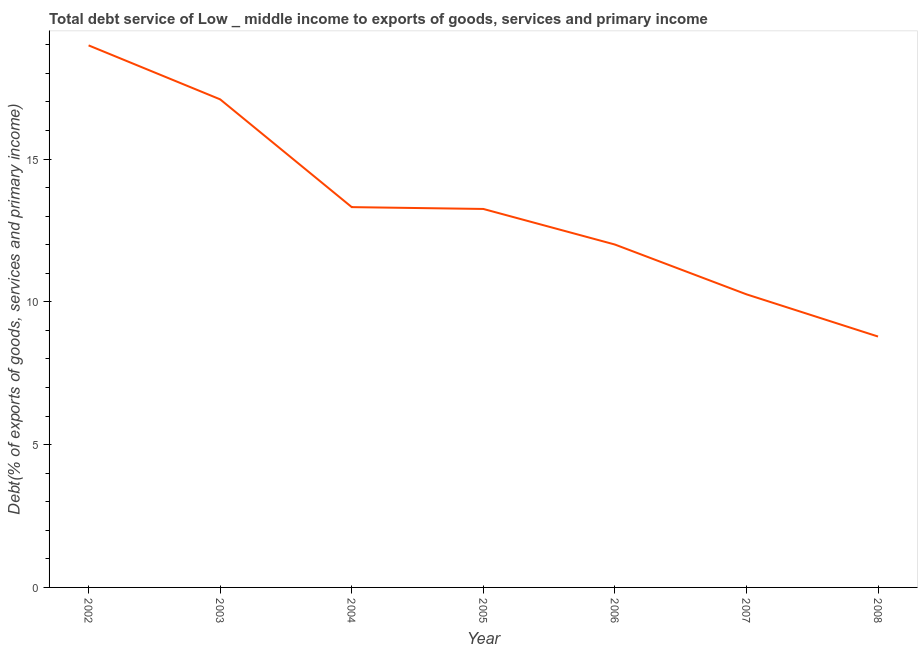What is the total debt service in 2002?
Offer a very short reply. 18.98. Across all years, what is the maximum total debt service?
Provide a succinct answer. 18.98. Across all years, what is the minimum total debt service?
Your answer should be very brief. 8.79. In which year was the total debt service minimum?
Your response must be concise. 2008. What is the sum of the total debt service?
Ensure brevity in your answer.  93.7. What is the difference between the total debt service in 2003 and 2005?
Provide a succinct answer. 3.84. What is the average total debt service per year?
Give a very brief answer. 13.39. What is the median total debt service?
Offer a very short reply. 13.25. In how many years, is the total debt service greater than 14 %?
Your answer should be very brief. 2. Do a majority of the years between 2006 and 2008 (inclusive) have total debt service greater than 17 %?
Give a very brief answer. No. What is the ratio of the total debt service in 2003 to that in 2008?
Offer a terse response. 1.95. Is the difference between the total debt service in 2007 and 2008 greater than the difference between any two years?
Your answer should be compact. No. What is the difference between the highest and the second highest total debt service?
Provide a succinct answer. 1.89. What is the difference between the highest and the lowest total debt service?
Make the answer very short. 10.2. Does the total debt service monotonically increase over the years?
Your answer should be very brief. No. How many lines are there?
Offer a very short reply. 1. Are the values on the major ticks of Y-axis written in scientific E-notation?
Ensure brevity in your answer.  No. What is the title of the graph?
Provide a short and direct response. Total debt service of Low _ middle income to exports of goods, services and primary income. What is the label or title of the X-axis?
Your response must be concise. Year. What is the label or title of the Y-axis?
Offer a very short reply. Debt(% of exports of goods, services and primary income). What is the Debt(% of exports of goods, services and primary income) in 2002?
Offer a terse response. 18.98. What is the Debt(% of exports of goods, services and primary income) in 2003?
Make the answer very short. 17.09. What is the Debt(% of exports of goods, services and primary income) of 2004?
Give a very brief answer. 13.32. What is the Debt(% of exports of goods, services and primary income) in 2005?
Offer a terse response. 13.25. What is the Debt(% of exports of goods, services and primary income) in 2006?
Your response must be concise. 12.01. What is the Debt(% of exports of goods, services and primary income) of 2007?
Offer a terse response. 10.26. What is the Debt(% of exports of goods, services and primary income) in 2008?
Your answer should be compact. 8.79. What is the difference between the Debt(% of exports of goods, services and primary income) in 2002 and 2003?
Ensure brevity in your answer.  1.89. What is the difference between the Debt(% of exports of goods, services and primary income) in 2002 and 2004?
Offer a terse response. 5.66. What is the difference between the Debt(% of exports of goods, services and primary income) in 2002 and 2005?
Your response must be concise. 5.73. What is the difference between the Debt(% of exports of goods, services and primary income) in 2002 and 2006?
Your answer should be compact. 6.97. What is the difference between the Debt(% of exports of goods, services and primary income) in 2002 and 2007?
Provide a short and direct response. 8.72. What is the difference between the Debt(% of exports of goods, services and primary income) in 2002 and 2008?
Give a very brief answer. 10.2. What is the difference between the Debt(% of exports of goods, services and primary income) in 2003 and 2004?
Offer a terse response. 3.77. What is the difference between the Debt(% of exports of goods, services and primary income) in 2003 and 2005?
Provide a short and direct response. 3.84. What is the difference between the Debt(% of exports of goods, services and primary income) in 2003 and 2006?
Give a very brief answer. 5.08. What is the difference between the Debt(% of exports of goods, services and primary income) in 2003 and 2007?
Offer a very short reply. 6.83. What is the difference between the Debt(% of exports of goods, services and primary income) in 2003 and 2008?
Make the answer very short. 8.31. What is the difference between the Debt(% of exports of goods, services and primary income) in 2004 and 2005?
Your answer should be compact. 0.06. What is the difference between the Debt(% of exports of goods, services and primary income) in 2004 and 2006?
Ensure brevity in your answer.  1.31. What is the difference between the Debt(% of exports of goods, services and primary income) in 2004 and 2007?
Make the answer very short. 3.05. What is the difference between the Debt(% of exports of goods, services and primary income) in 2004 and 2008?
Provide a short and direct response. 4.53. What is the difference between the Debt(% of exports of goods, services and primary income) in 2005 and 2006?
Your answer should be very brief. 1.25. What is the difference between the Debt(% of exports of goods, services and primary income) in 2005 and 2007?
Ensure brevity in your answer.  2.99. What is the difference between the Debt(% of exports of goods, services and primary income) in 2005 and 2008?
Ensure brevity in your answer.  4.47. What is the difference between the Debt(% of exports of goods, services and primary income) in 2006 and 2007?
Provide a succinct answer. 1.74. What is the difference between the Debt(% of exports of goods, services and primary income) in 2006 and 2008?
Give a very brief answer. 3.22. What is the difference between the Debt(% of exports of goods, services and primary income) in 2007 and 2008?
Make the answer very short. 1.48. What is the ratio of the Debt(% of exports of goods, services and primary income) in 2002 to that in 2003?
Provide a succinct answer. 1.11. What is the ratio of the Debt(% of exports of goods, services and primary income) in 2002 to that in 2004?
Keep it short and to the point. 1.43. What is the ratio of the Debt(% of exports of goods, services and primary income) in 2002 to that in 2005?
Provide a succinct answer. 1.43. What is the ratio of the Debt(% of exports of goods, services and primary income) in 2002 to that in 2006?
Your answer should be compact. 1.58. What is the ratio of the Debt(% of exports of goods, services and primary income) in 2002 to that in 2007?
Give a very brief answer. 1.85. What is the ratio of the Debt(% of exports of goods, services and primary income) in 2002 to that in 2008?
Offer a terse response. 2.16. What is the ratio of the Debt(% of exports of goods, services and primary income) in 2003 to that in 2004?
Give a very brief answer. 1.28. What is the ratio of the Debt(% of exports of goods, services and primary income) in 2003 to that in 2005?
Offer a terse response. 1.29. What is the ratio of the Debt(% of exports of goods, services and primary income) in 2003 to that in 2006?
Ensure brevity in your answer.  1.42. What is the ratio of the Debt(% of exports of goods, services and primary income) in 2003 to that in 2007?
Offer a terse response. 1.67. What is the ratio of the Debt(% of exports of goods, services and primary income) in 2003 to that in 2008?
Provide a succinct answer. 1.95. What is the ratio of the Debt(% of exports of goods, services and primary income) in 2004 to that in 2006?
Provide a succinct answer. 1.11. What is the ratio of the Debt(% of exports of goods, services and primary income) in 2004 to that in 2007?
Offer a terse response. 1.3. What is the ratio of the Debt(% of exports of goods, services and primary income) in 2004 to that in 2008?
Make the answer very short. 1.52. What is the ratio of the Debt(% of exports of goods, services and primary income) in 2005 to that in 2006?
Ensure brevity in your answer.  1.1. What is the ratio of the Debt(% of exports of goods, services and primary income) in 2005 to that in 2007?
Offer a very short reply. 1.29. What is the ratio of the Debt(% of exports of goods, services and primary income) in 2005 to that in 2008?
Give a very brief answer. 1.51. What is the ratio of the Debt(% of exports of goods, services and primary income) in 2006 to that in 2007?
Ensure brevity in your answer.  1.17. What is the ratio of the Debt(% of exports of goods, services and primary income) in 2006 to that in 2008?
Your response must be concise. 1.37. What is the ratio of the Debt(% of exports of goods, services and primary income) in 2007 to that in 2008?
Keep it short and to the point. 1.17. 